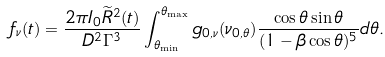Convert formula to latex. <formula><loc_0><loc_0><loc_500><loc_500>f _ { \nu } ( t ) = \frac { 2 \pi I _ { 0 } \widetilde { R } ^ { 2 } ( t ) } { D ^ { 2 } \Gamma ^ { 3 } } \int _ { \theta _ { \min } } ^ { \theta _ { \max } } g _ { 0 , \nu } ( \nu _ { 0 , \theta } ) \frac { \cos \theta \sin \theta } { ( 1 - \beta \cos \theta ) ^ { 5 } } d \theta .</formula> 